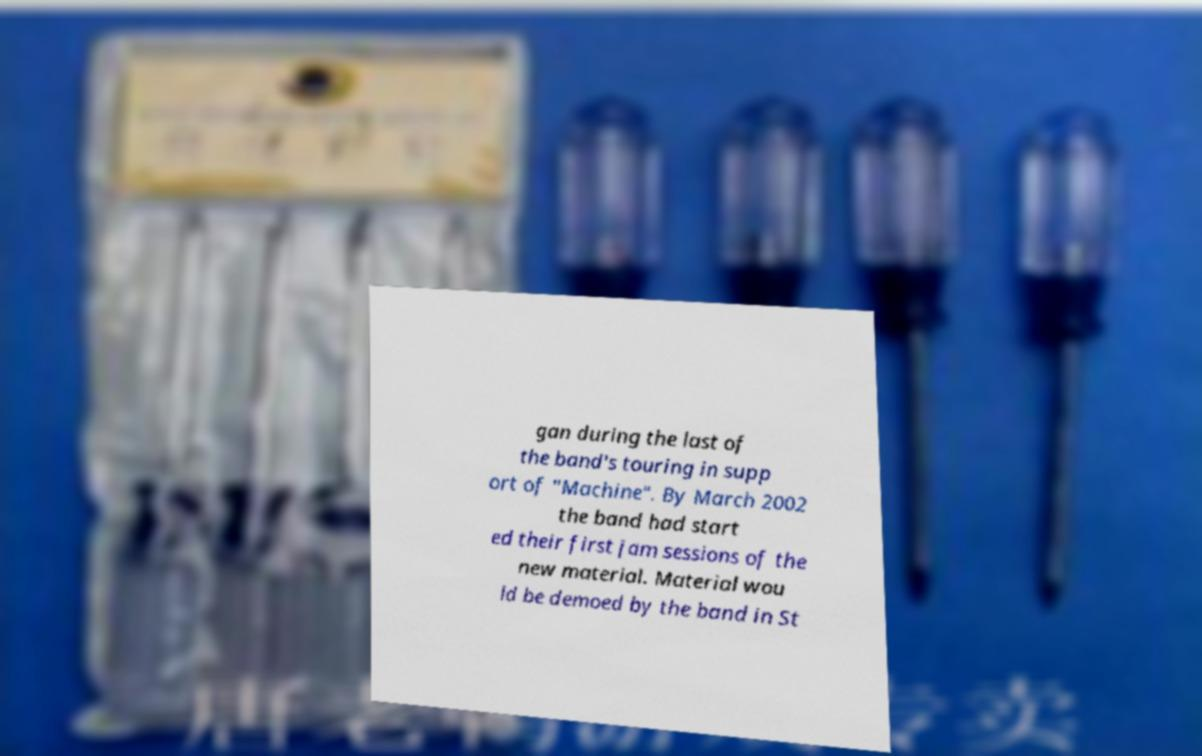Could you extract and type out the text from this image? gan during the last of the band's touring in supp ort of "Machine". By March 2002 the band had start ed their first jam sessions of the new material. Material wou ld be demoed by the band in St 